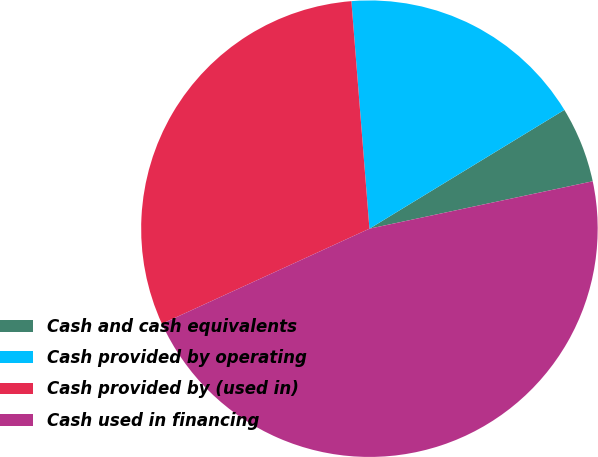Convert chart to OTSL. <chart><loc_0><loc_0><loc_500><loc_500><pie_chart><fcel>Cash and cash equivalents<fcel>Cash provided by operating<fcel>Cash provided by (used in)<fcel>Cash used in financing<nl><fcel>5.38%<fcel>17.55%<fcel>30.58%<fcel>46.49%<nl></chart> 